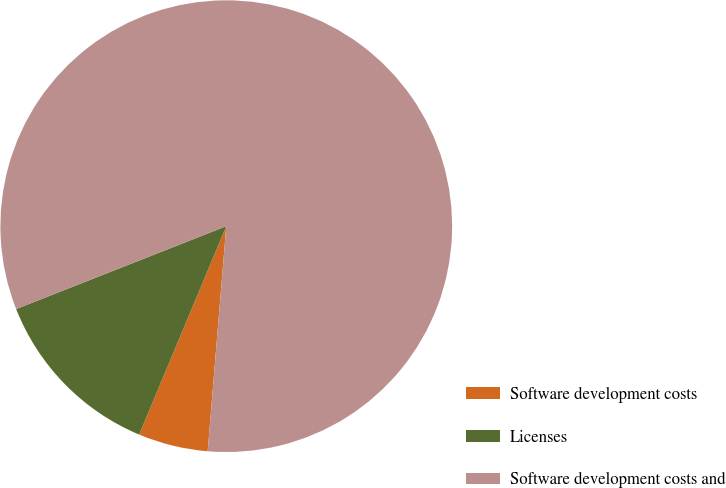Convert chart. <chart><loc_0><loc_0><loc_500><loc_500><pie_chart><fcel>Software development costs<fcel>Licenses<fcel>Software development costs and<nl><fcel>4.99%<fcel>12.72%<fcel>82.29%<nl></chart> 